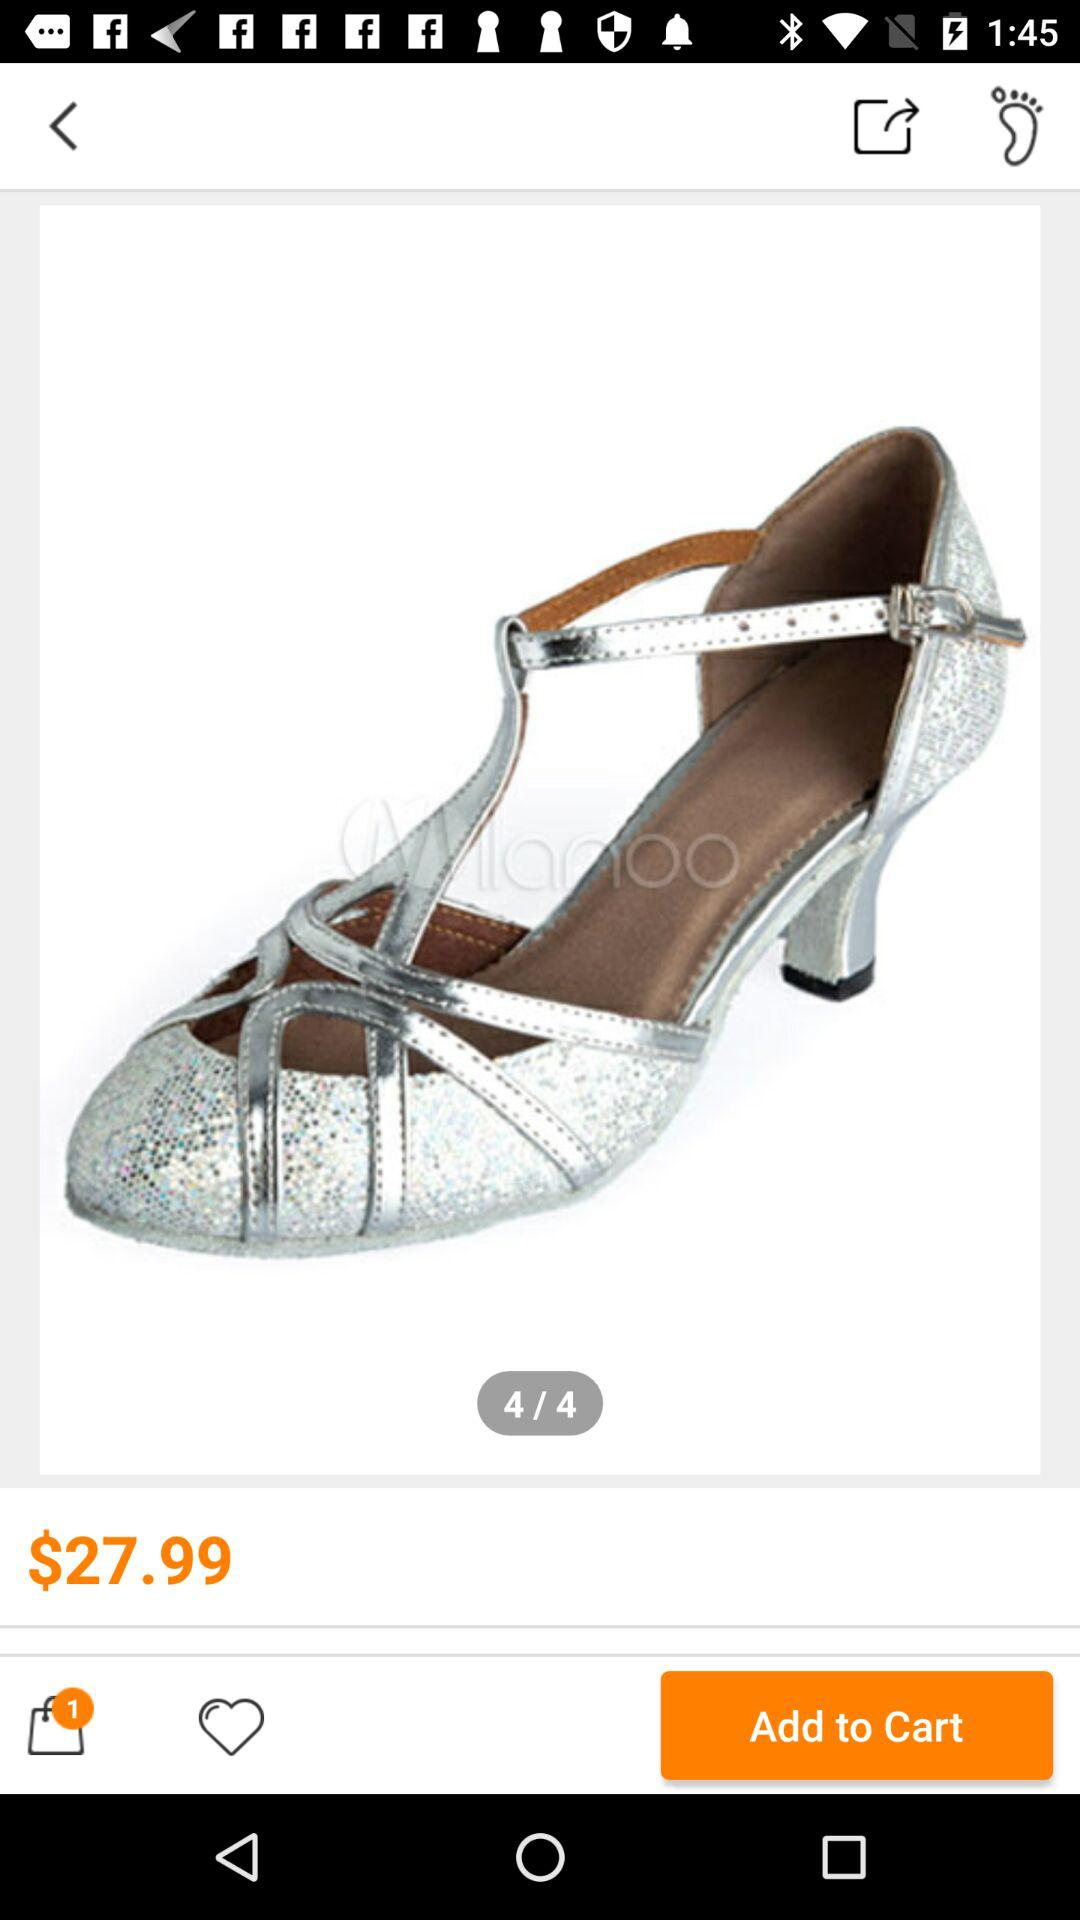How many items are in the shopping cart?
Answer the question using a single word or phrase. 1 